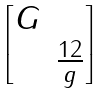Convert formula to latex. <formula><loc_0><loc_0><loc_500><loc_500>\begin{bmatrix} G & \\ & \frac { 1 2 } { g } \\ \end{bmatrix}</formula> 